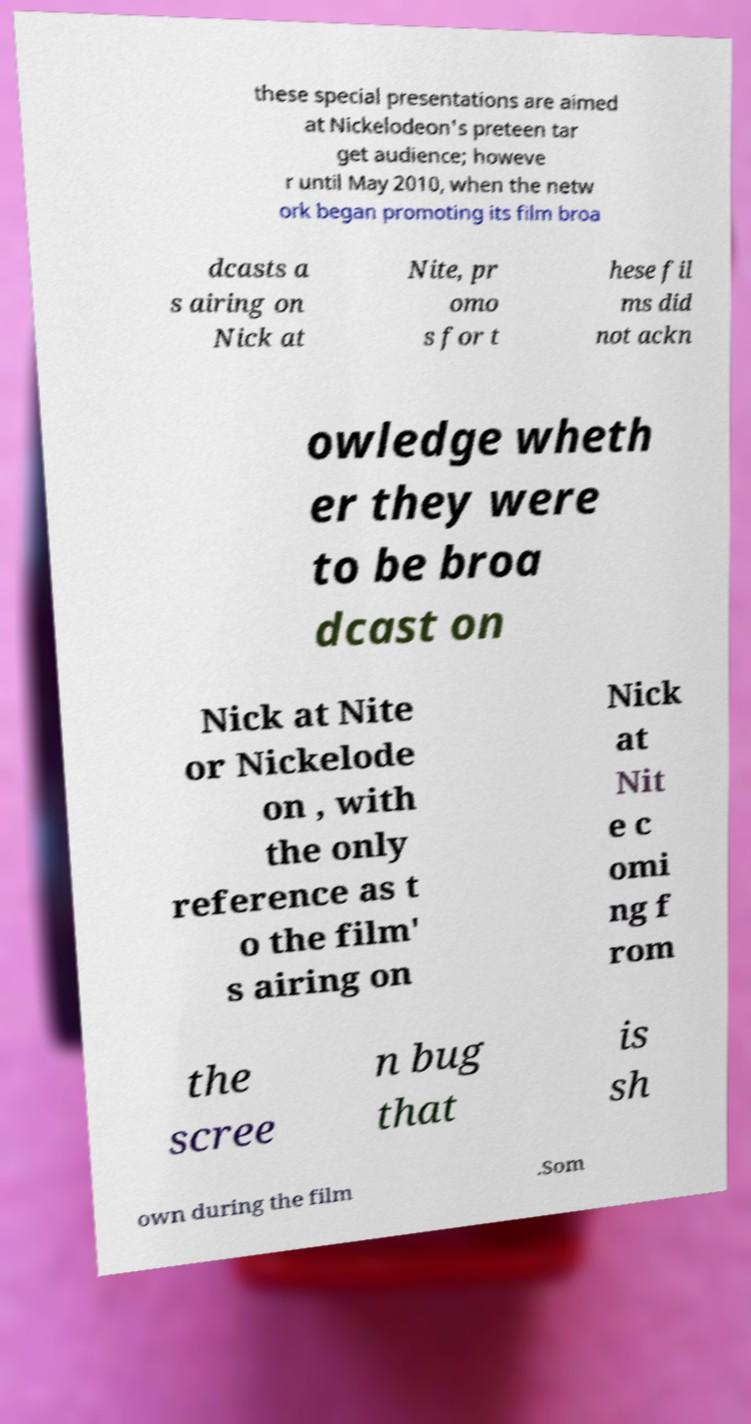Can you read and provide the text displayed in the image?This photo seems to have some interesting text. Can you extract and type it out for me? these special presentations are aimed at Nickelodeon's preteen tar get audience; howeve r until May 2010, when the netw ork began promoting its film broa dcasts a s airing on Nick at Nite, pr omo s for t hese fil ms did not ackn owledge wheth er they were to be broa dcast on Nick at Nite or Nickelode on , with the only reference as t o the film' s airing on Nick at Nit e c omi ng f rom the scree n bug that is sh own during the film .Som 